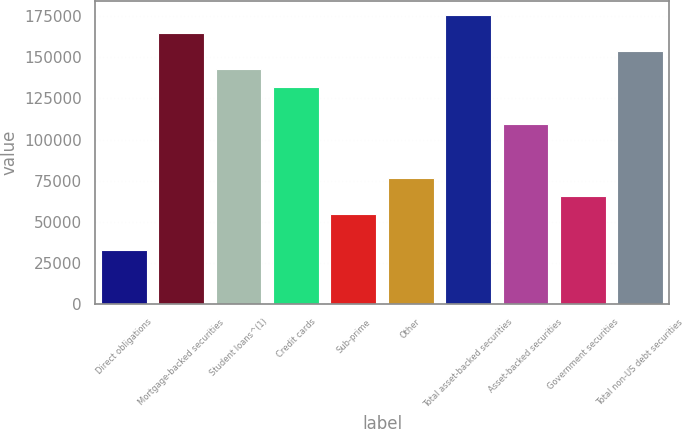Convert chart. <chart><loc_0><loc_0><loc_500><loc_500><bar_chart><fcel>Direct obligations<fcel>Mortgage-backed securities<fcel>Student loans^(1)<fcel>Credit cards<fcel>Sub-prime<fcel>Other<fcel>Total asset-backed securities<fcel>Asset-backed securities<fcel>Government securities<fcel>Total non-US debt securities<nl><fcel>32905.3<fcel>164522<fcel>142586<fcel>131618<fcel>54841.5<fcel>76777.7<fcel>175491<fcel>109682<fcel>65809.6<fcel>153554<nl></chart> 